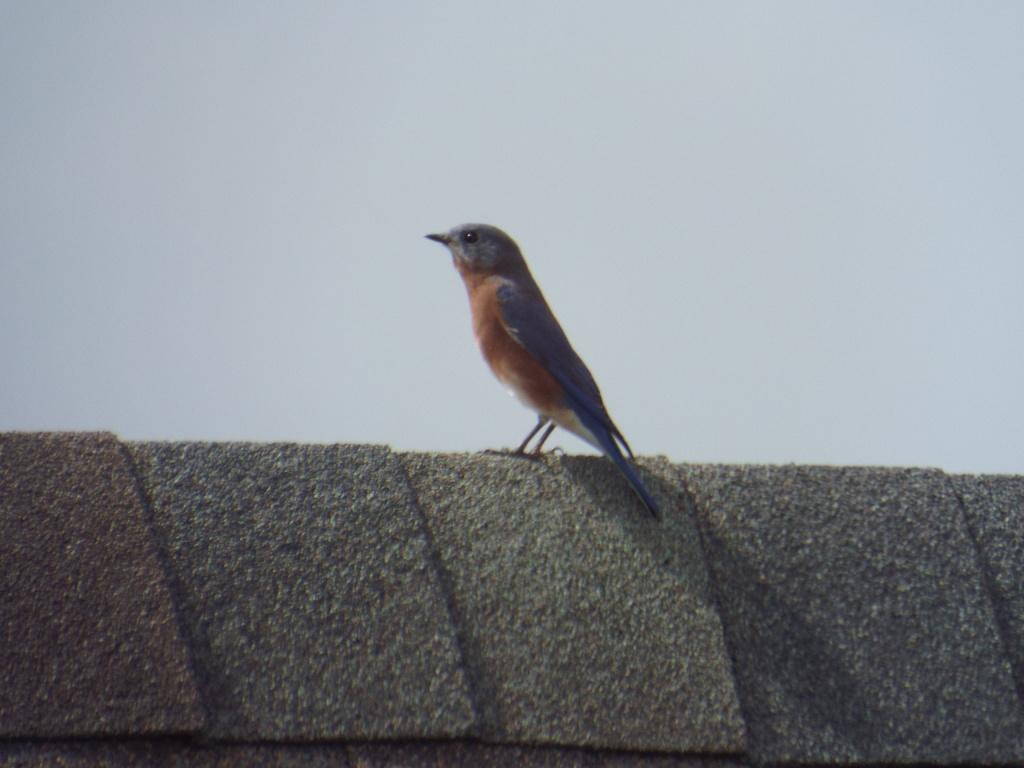What type of animal is in the image? There is a bird in the image. What colors can be seen on the bird? The bird has blue, brown, black, and white colors. What is the bird standing on in the image? The bird is standing on a concrete wall. What can be seen in the background of the image? The sky is visible in the background of the image. How many arches can be seen supporting the bird in the image? There are no arches present in the image; the bird is standing on a concrete wall. What type of coin is visible in the image? There is no coin present in the image. 